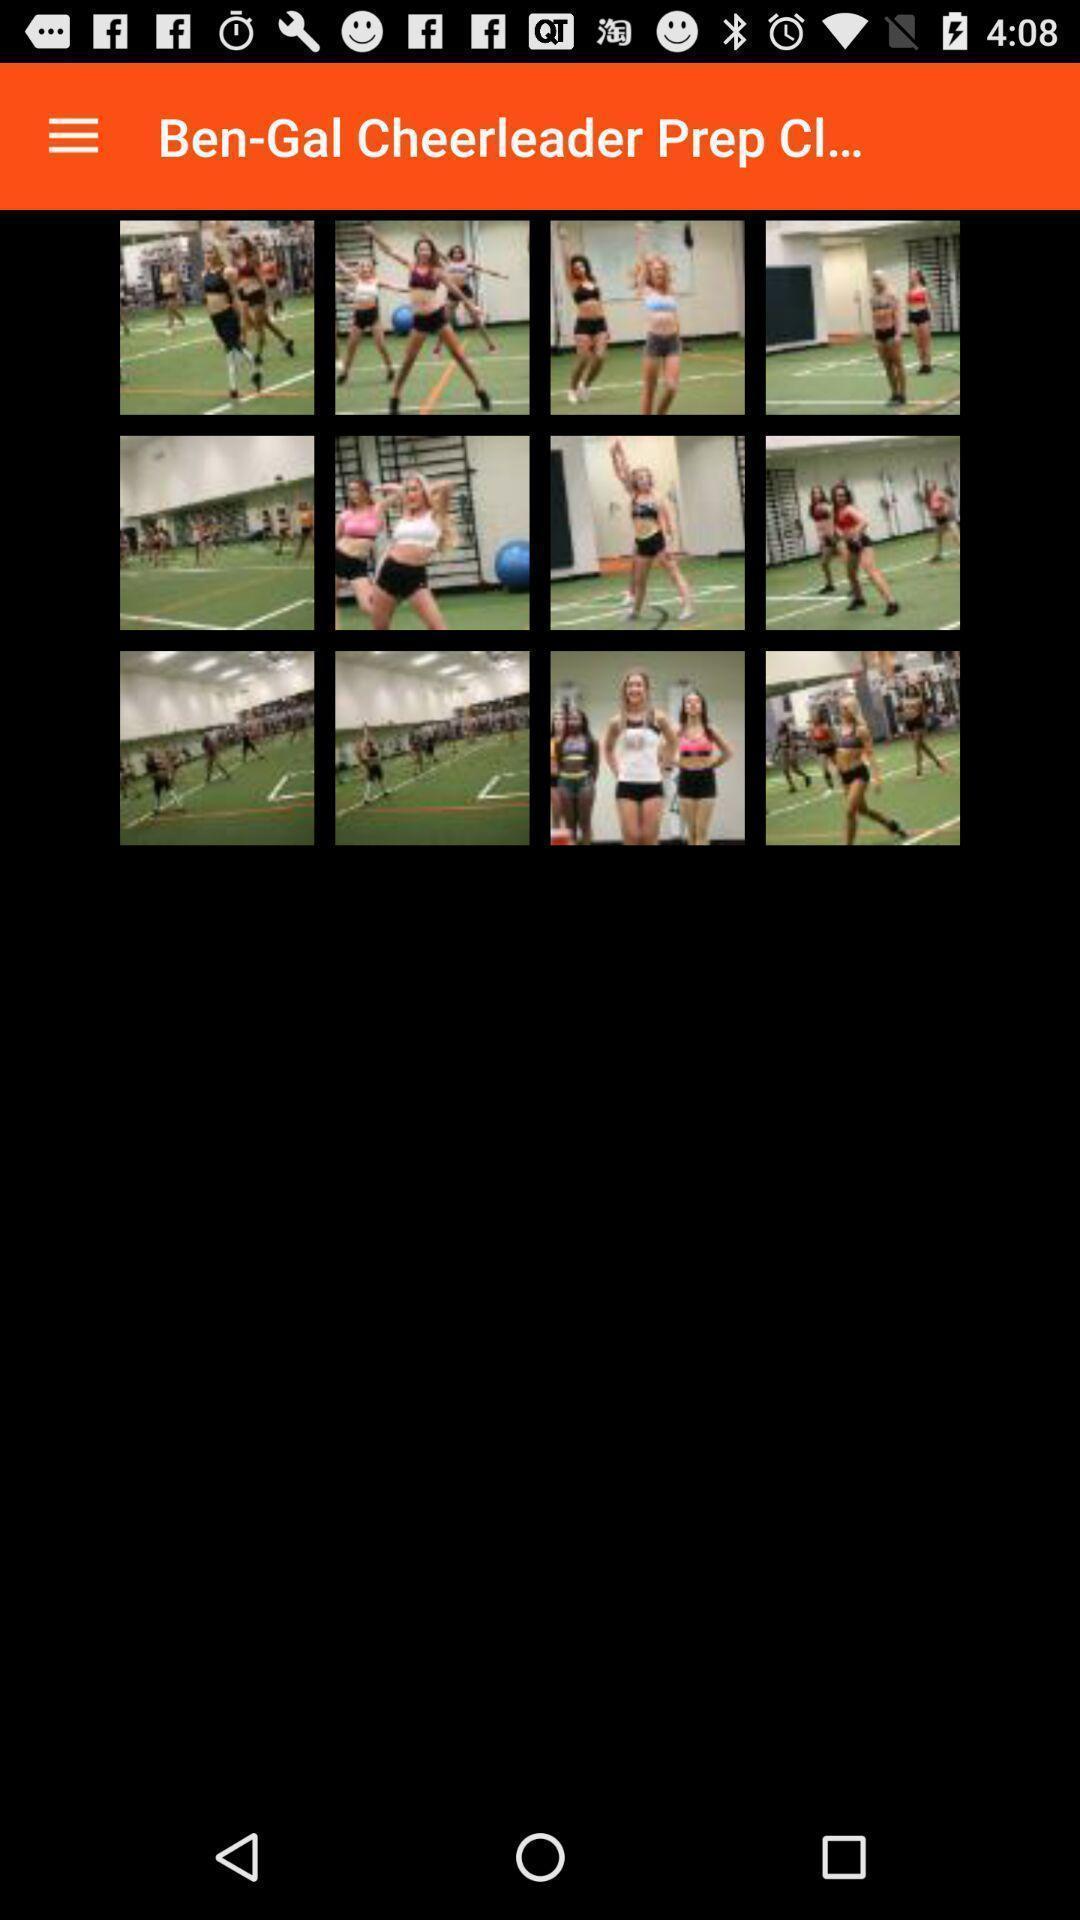Describe this image in words. Page shows images of cheerleaders in the sports app. 